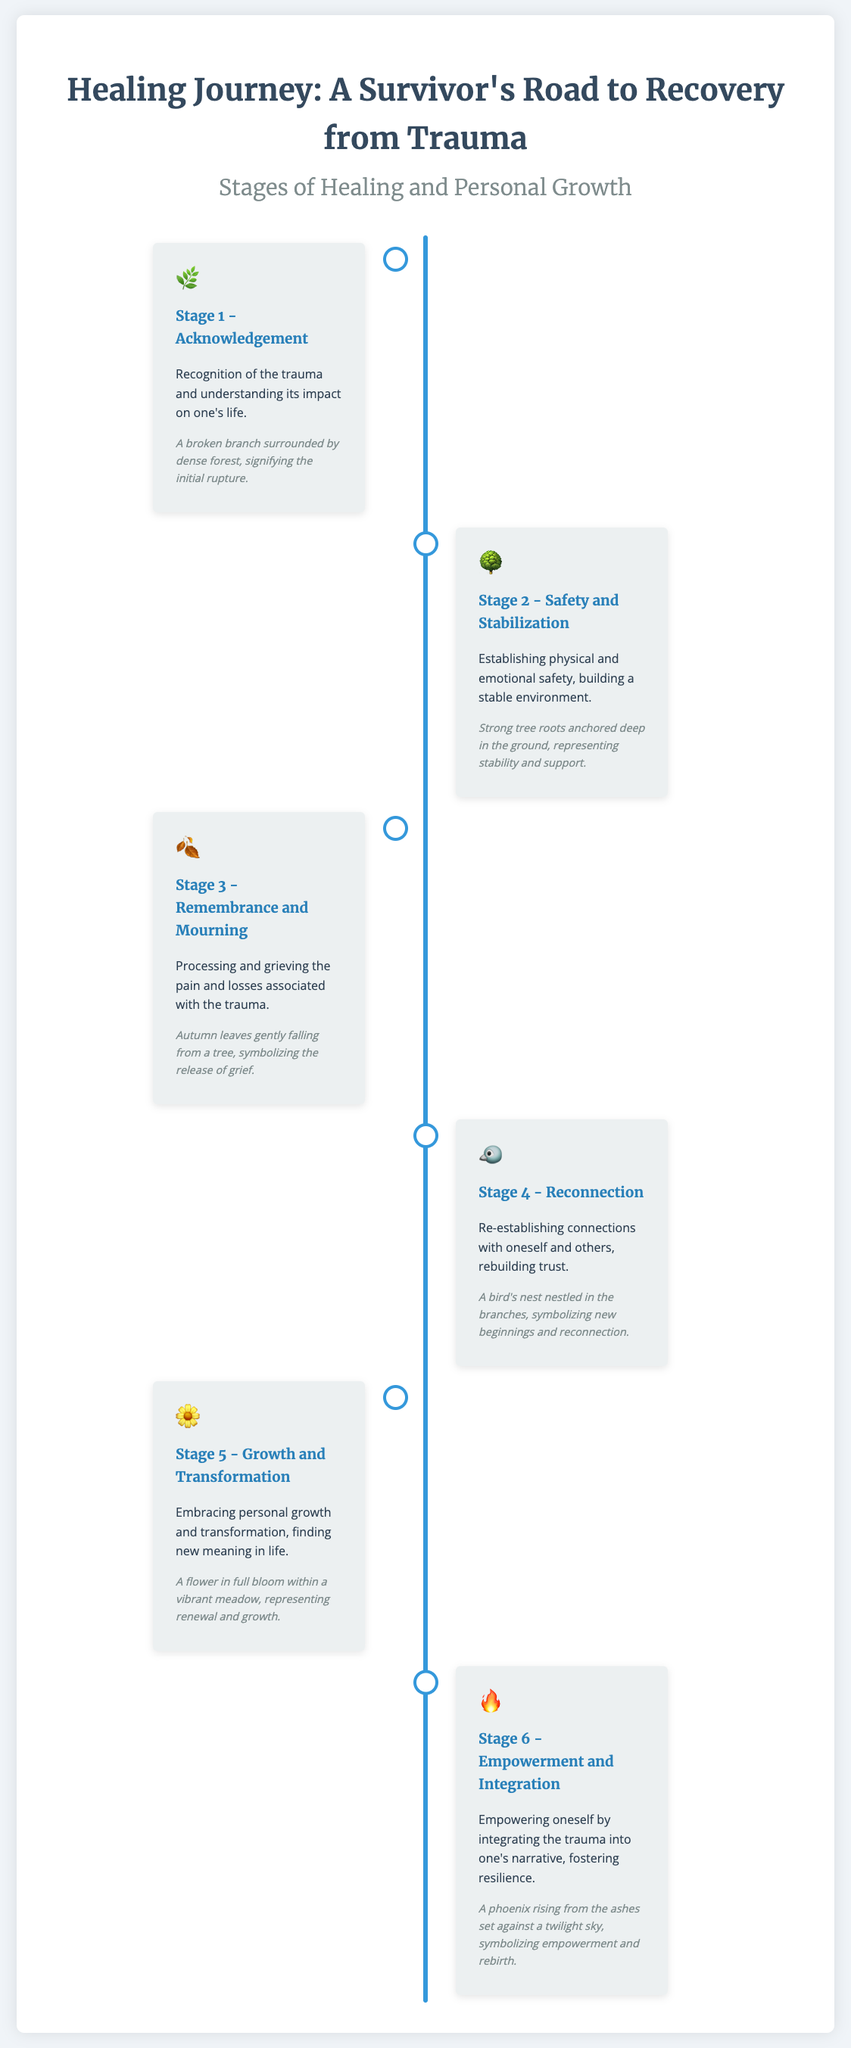What is the title of the document? The title is clearly stated at the top of the document, which is about the healing journey from trauma.
Answer: Healing Journey: A Survivor's Road to Recovery from Trauma How many stages of healing are listed? The document outlines a total of six distinct stages of healing.
Answer: 6 What symbol represents Stage 3? Each stage has a corresponding symbol, and the symbol for Stage 3 is identified in the document.
Answer: 🍂 What does a bird's nest symbolize in Stage 4? The document explains that the bird's nest represents a specific theme related to the stage's focus on connection.
Answer: New beginnings and reconnection Which imagery represents Stage 5? Each stage features an imagery description, and Stage 5 is connected to a specific natural image.
Answer: A flower in full bloom within a vibrant meadow What is the focus of Stage 6? The document provides a brief description of each stage, including this stage's core theme related to empowerment and narrative integration.
Answer: Empowerment and Integration What natural element symbolizes stability in Stage 2? The imagery associated with this stage is indicative of a natural aspect that symbolizes stability.
Answer: Strong tree roots What feeling does autumn leaves convey in Stage 3? The document describes the emotional significance of the imagery linked to this stage.
Answer: Release of grief 